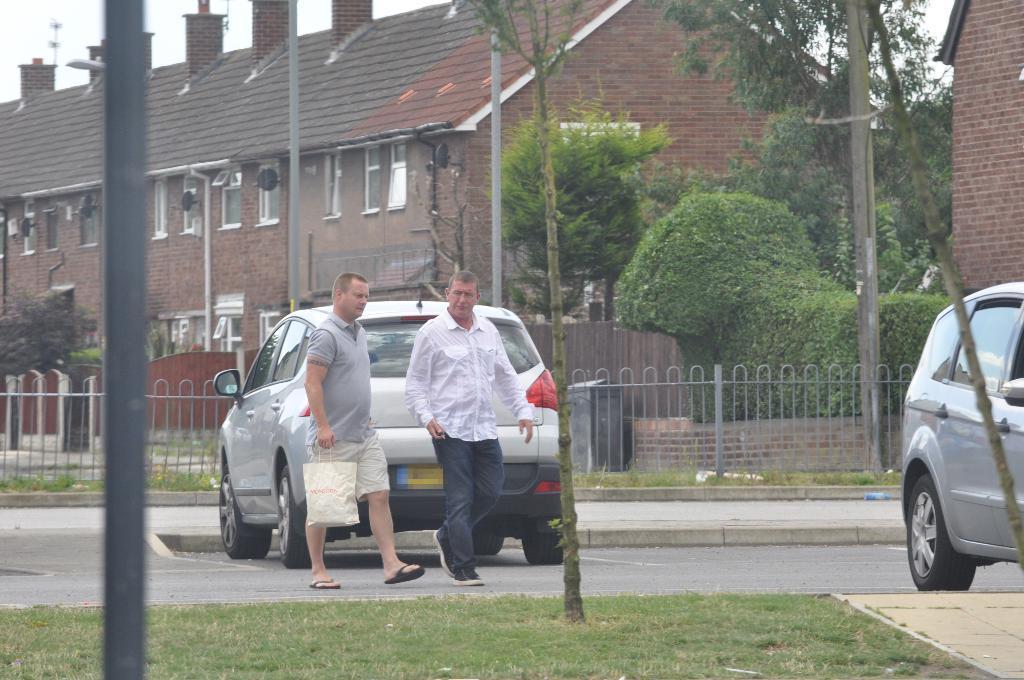In one or two sentences, can you explain what this image depicts? This is a picture taken outside a city. In the foreground of the picture there are cars, men, trees, grass, road, footpath, railing and a pole. In the center of the picture there are trees, grass, building, windows, poles and chimney. On the right there is a brick wall. 